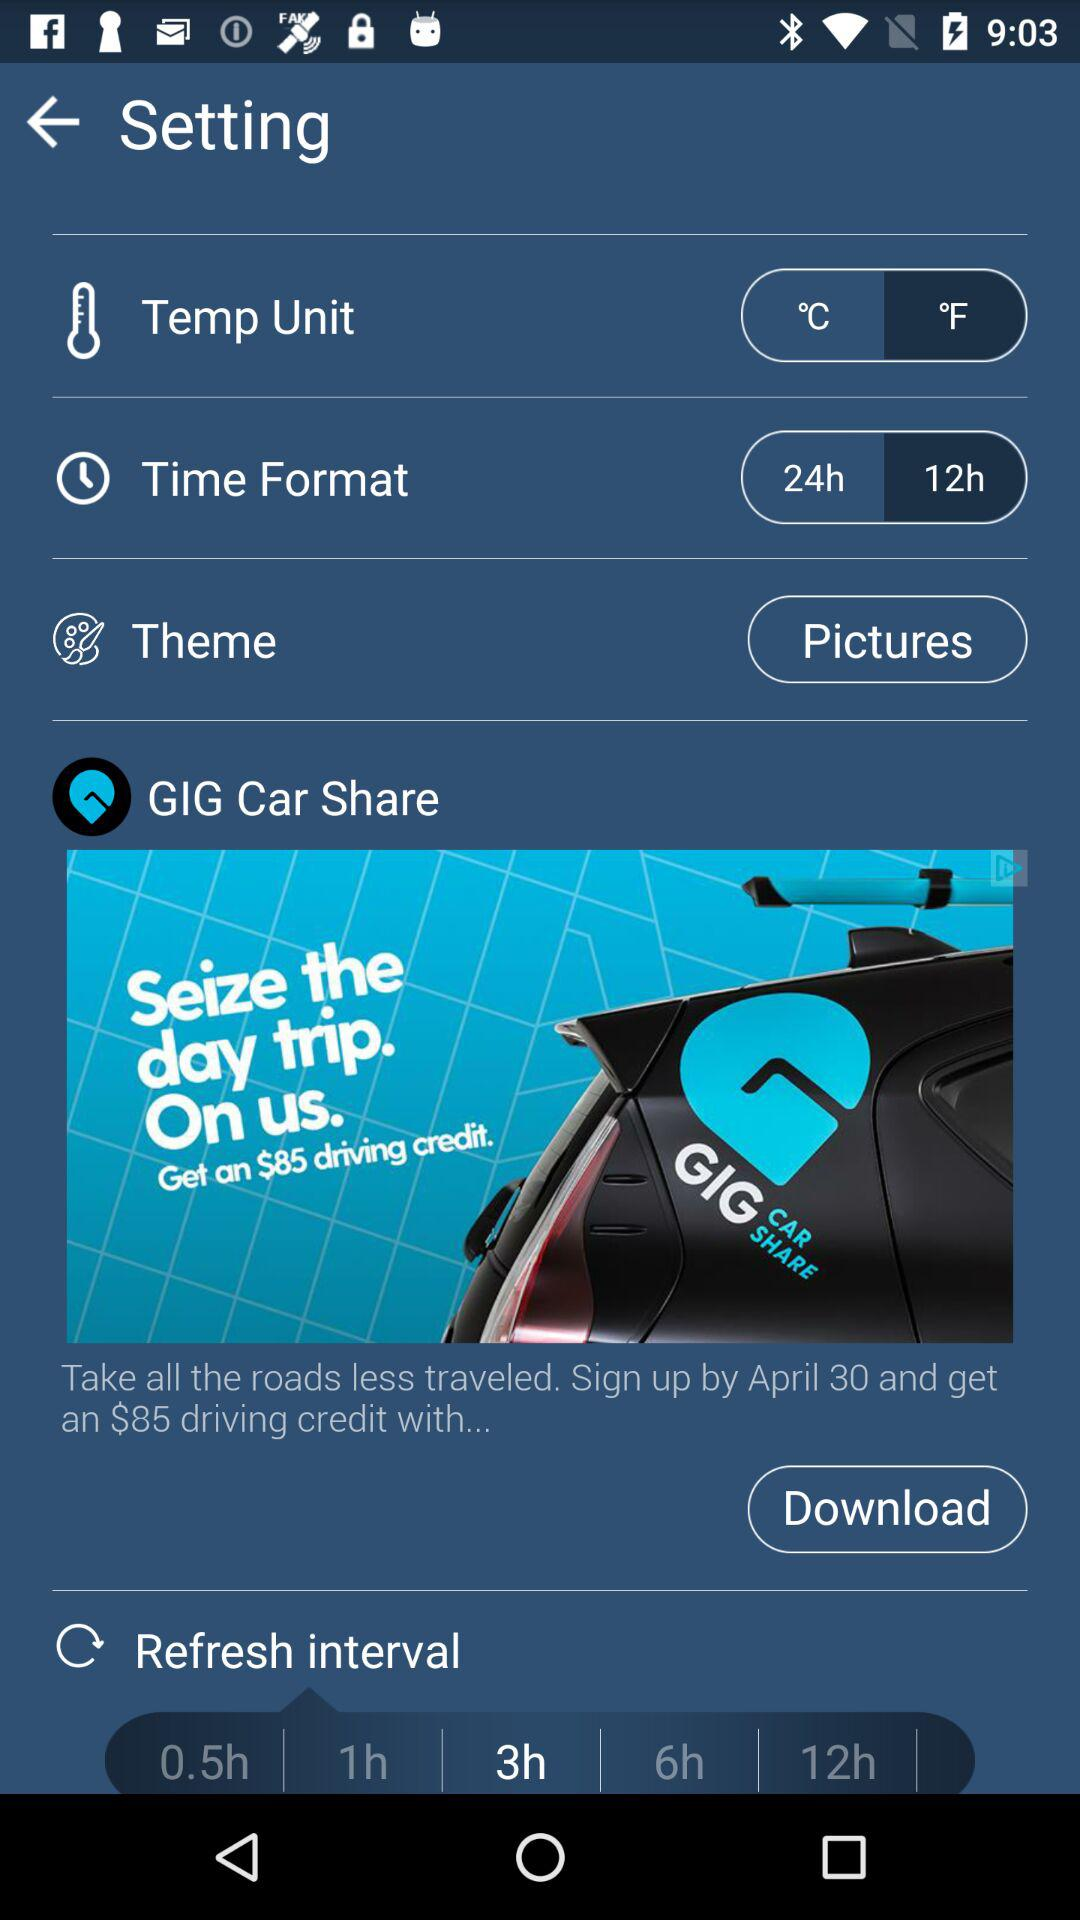What is the selected "Refresh interval"? The selected "Refresh interval" is 3 hours. 